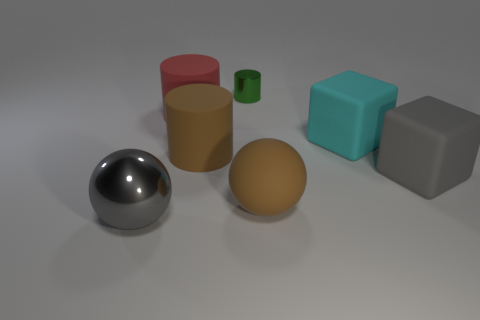Is there any other thing that is the same shape as the large gray rubber thing?
Make the answer very short. Yes. Is the material of the large cyan cube the same as the brown thing that is behind the big gray rubber object?
Provide a succinct answer. Yes. There is a sphere that is left of the green cylinder; is its color the same as the tiny metal cylinder?
Give a very brief answer. No. What number of large gray things are to the right of the cyan matte block and left of the big cyan object?
Your answer should be compact. 0. What number of other things are there of the same material as the red thing
Offer a very short reply. 4. Does the large ball that is right of the gray ball have the same material as the brown cylinder?
Your answer should be very brief. Yes. There is a gray object in front of the big gray object behind the thing that is in front of the large brown ball; how big is it?
Offer a very short reply. Large. How many other objects are there of the same color as the big rubber ball?
Your answer should be very brief. 1. There is a gray matte thing that is the same size as the cyan cube; what shape is it?
Give a very brief answer. Cube. There is a gray thing that is to the right of the large shiny object; how big is it?
Give a very brief answer. Large. 